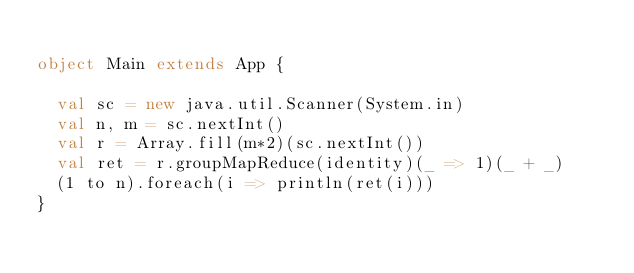Convert code to text. <code><loc_0><loc_0><loc_500><loc_500><_Scala_>
object Main extends App {
  
  val sc = new java.util.Scanner(System.in)
  val n, m = sc.nextInt()
  val r = Array.fill(m*2)(sc.nextInt())
  val ret = r.groupMapReduce(identity)(_ => 1)(_ + _)
  (1 to n).foreach(i => println(ret(i)))
}</code> 